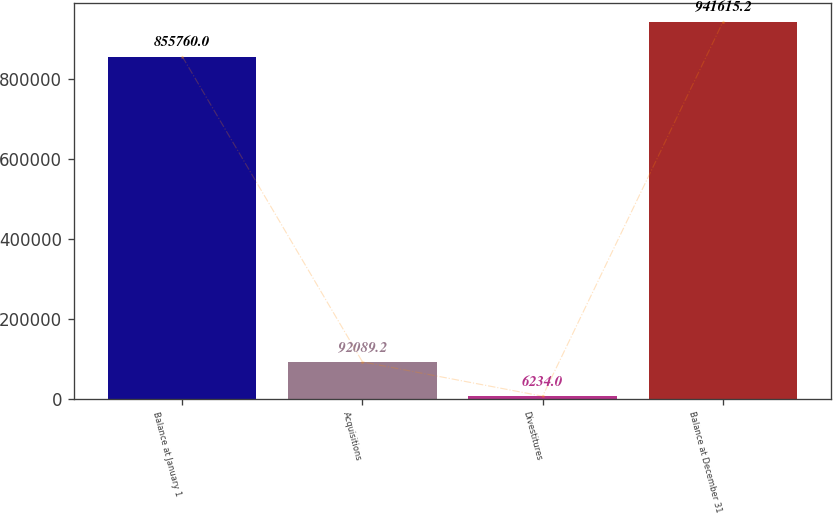<chart> <loc_0><loc_0><loc_500><loc_500><bar_chart><fcel>Balance at January 1<fcel>Acquisitions<fcel>Divestitures<fcel>Balance at December 31<nl><fcel>855760<fcel>92089.2<fcel>6234<fcel>941615<nl></chart> 